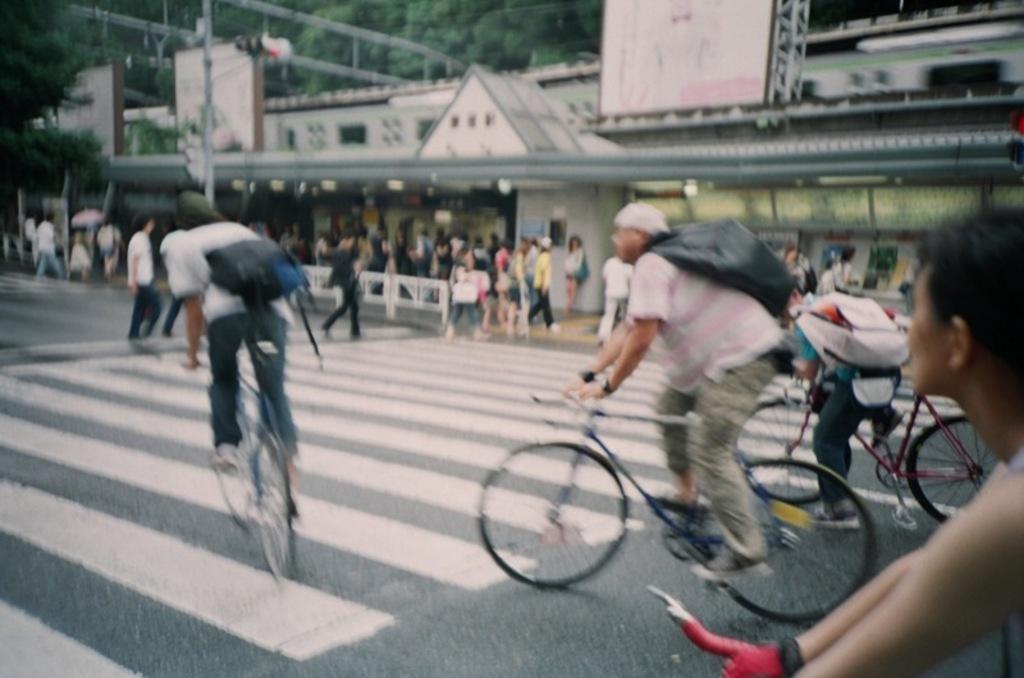In one or two sentences, can you explain what this image depicts? In this image I see number of people, in which few of them are on cycles and rest of them are on the path. In the background I see the trees and the train. 